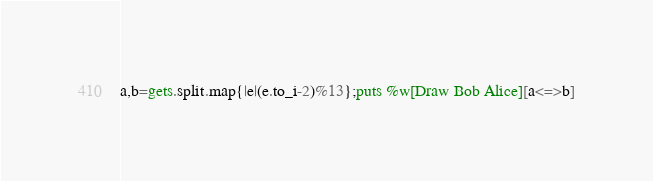<code> <loc_0><loc_0><loc_500><loc_500><_Ruby_>a,b=gets.split.map{|e|(e.to_i-2)%13};puts %w[Draw Bob Alice][a<=>b]</code> 